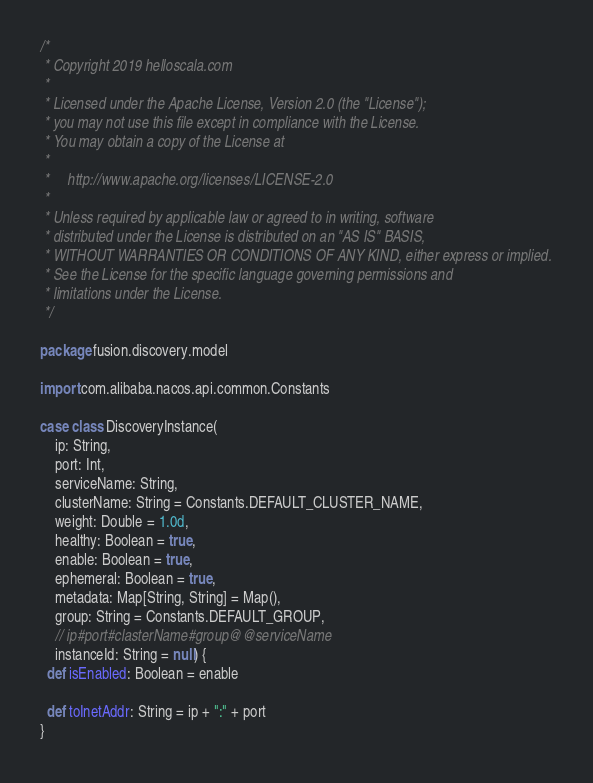Convert code to text. <code><loc_0><loc_0><loc_500><loc_500><_Scala_>/*
 * Copyright 2019 helloscala.com
 *
 * Licensed under the Apache License, Version 2.0 (the "License");
 * you may not use this file except in compliance with the License.
 * You may obtain a copy of the License at
 *
 *     http://www.apache.org/licenses/LICENSE-2.0
 *
 * Unless required by applicable law or agreed to in writing, software
 * distributed under the License is distributed on an "AS IS" BASIS,
 * WITHOUT WARRANTIES OR CONDITIONS OF ANY KIND, either express or implied.
 * See the License for the specific language governing permissions and
 * limitations under the License.
 */

package fusion.discovery.model

import com.alibaba.nacos.api.common.Constants

case class DiscoveryInstance(
    ip: String,
    port: Int,
    serviceName: String,
    clusterName: String = Constants.DEFAULT_CLUSTER_NAME,
    weight: Double = 1.0d,
    healthy: Boolean = true,
    enable: Boolean = true,
    ephemeral: Boolean = true,
    metadata: Map[String, String] = Map(),
    group: String = Constants.DEFAULT_GROUP,
    // ip#port#clasterName#group@@serviceName
    instanceId: String = null) {
  def isEnabled: Boolean = enable

  def toInetAddr: String = ip + ":" + port
}
</code> 